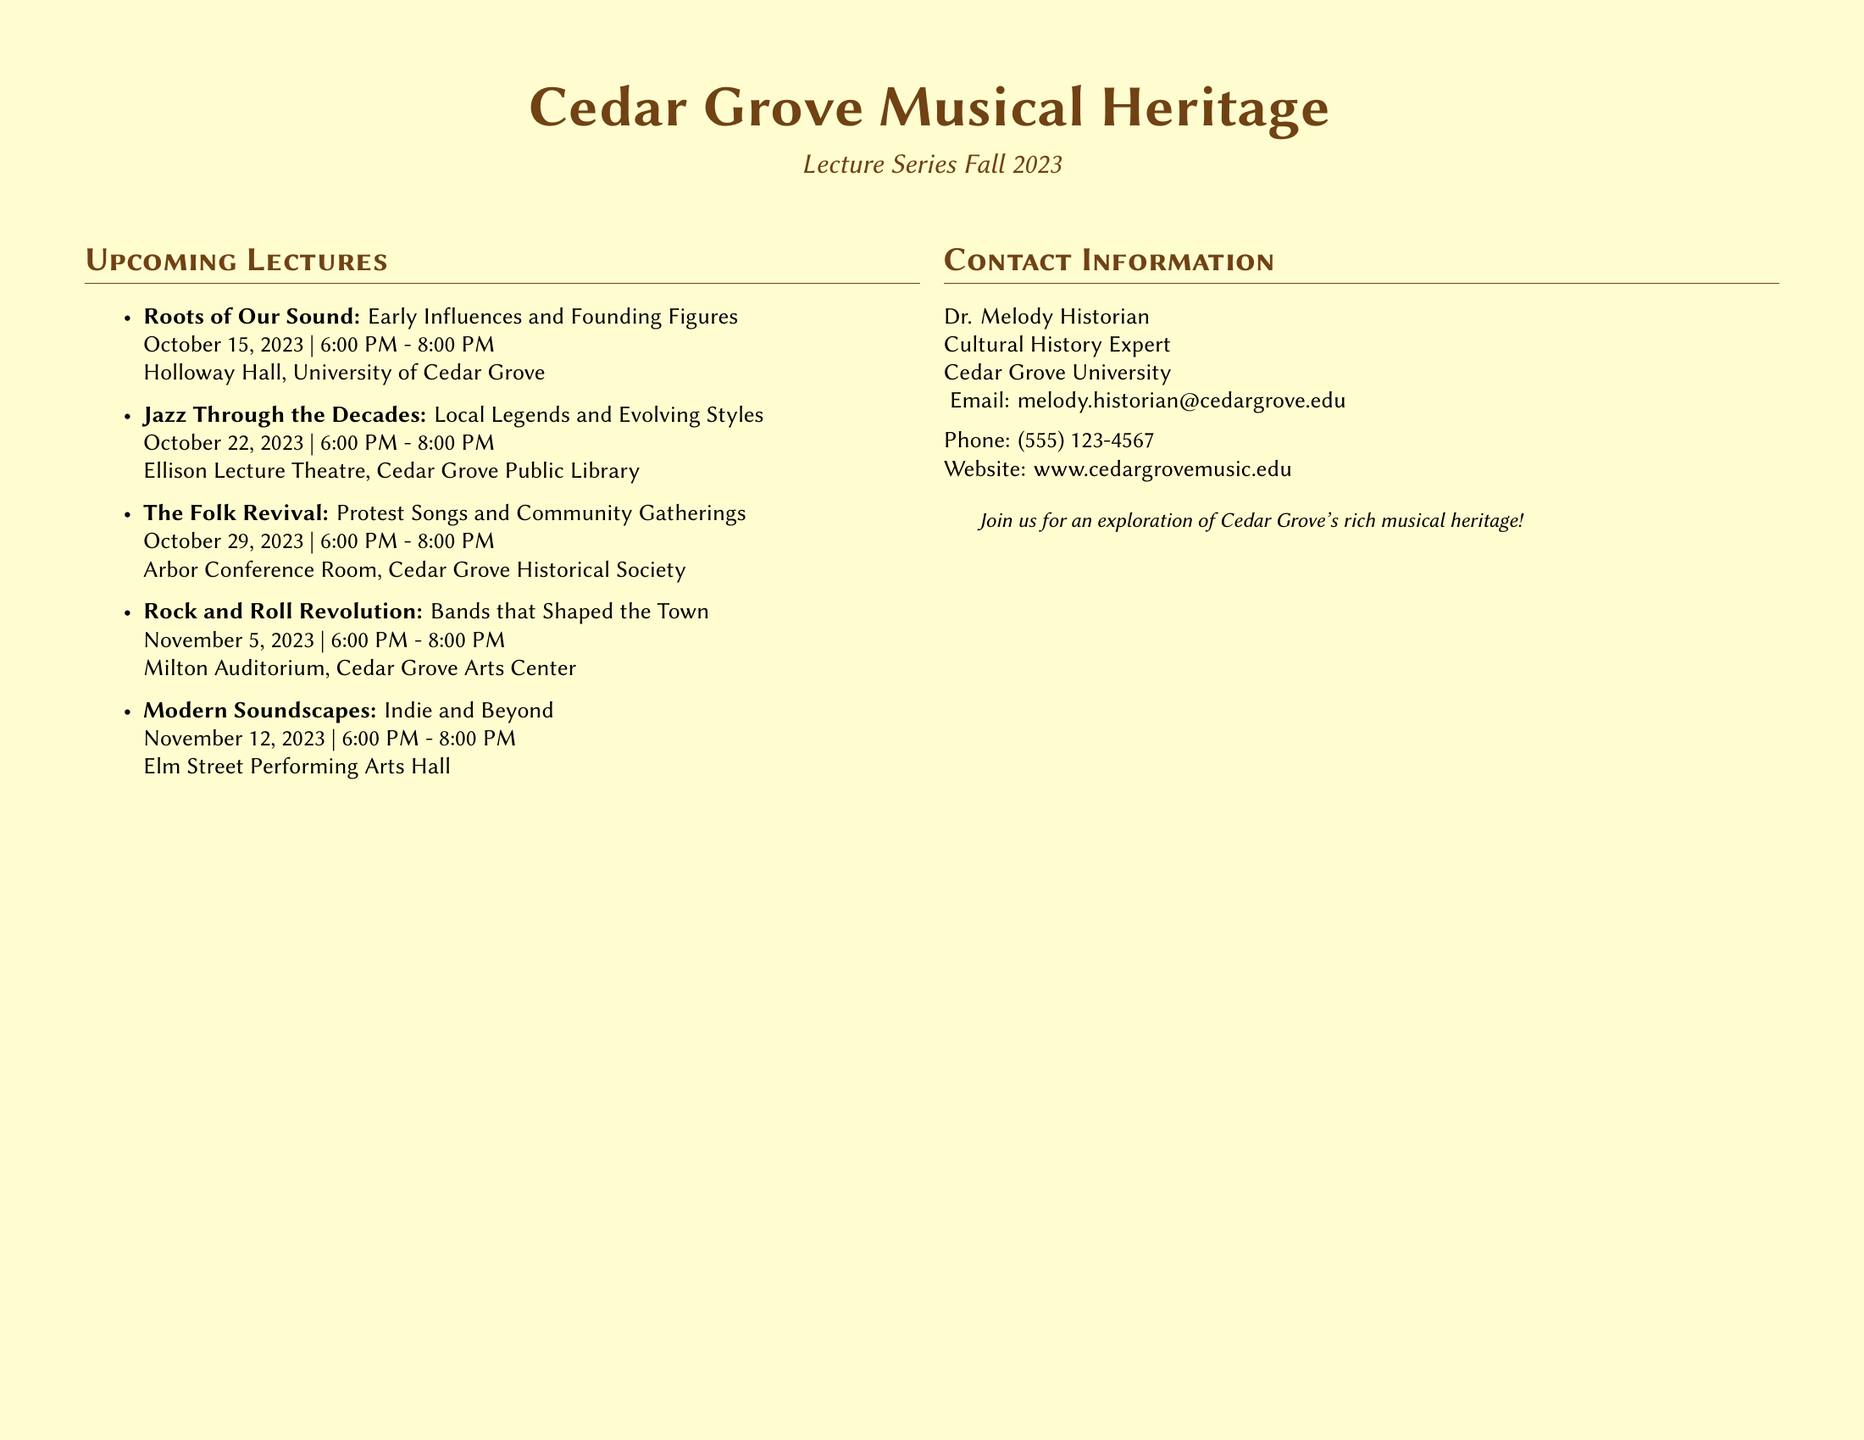What is the title of the lecture series? The title of the lecture series is prominently displayed at the top of the document.
Answer: Cedar Grove Musical Heritage Who is presenting the lecture series? The presenter’s name is included in the contact information section of the document.
Answer: Dr. Melody Historian Where will the Rock and Roll Revolution lecture take place? The venue for this specific lecture is specified in the upcoming lectures section.
Answer: Milton Auditorium, Cedar Grove Arts Center What is the main theme of the Folk Revival lecture? The main theme is described in the title of the lecture.
Answer: Protest Songs and Community Gatherings How many lectures are listed in the document? This can be determined by counting the items in the upcoming lectures section.
Answer: Five What is the website for more information? The website address is included in the contact information section.
Answer: www.cedargrovemusic.edu What format is the document printed in? The document type is noted at the start and implies a specific aesthetic choice.
Answer: Landscape What color scheme is used in the document? The colors are mentioned in the design specifications throughout the document.
Answer: Sepia and cream 